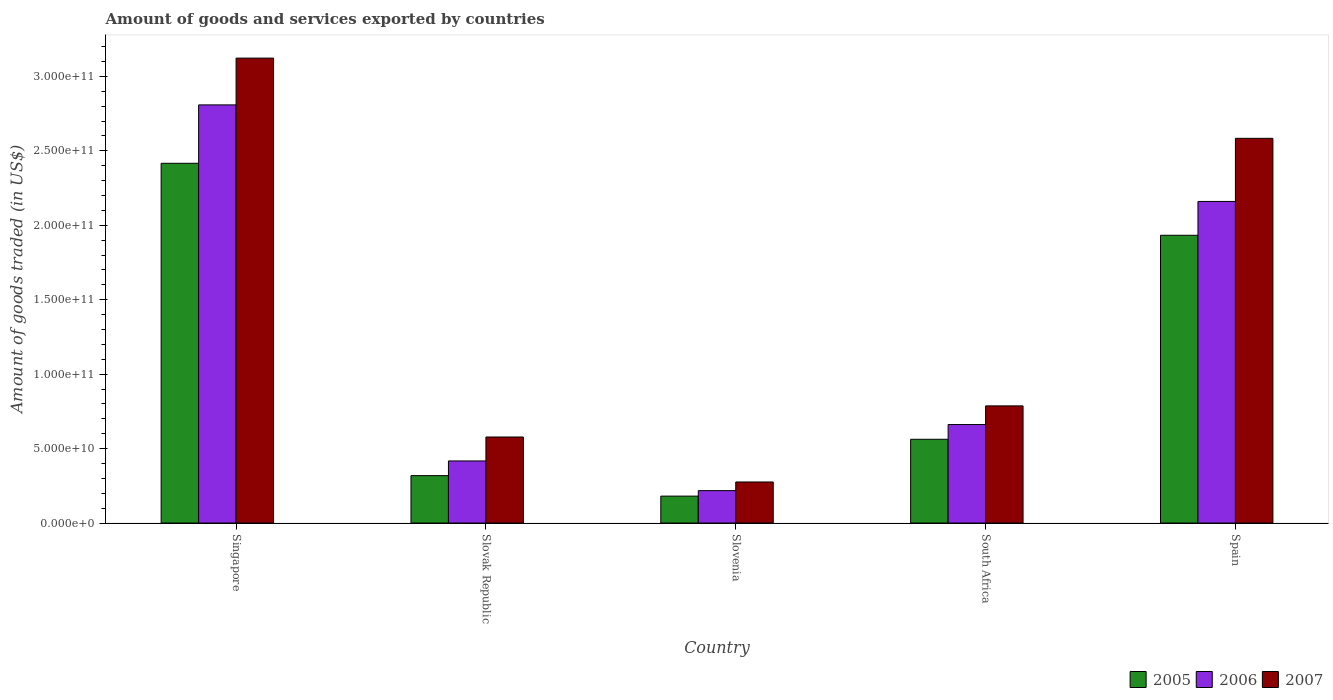How many different coloured bars are there?
Your response must be concise. 3. How many groups of bars are there?
Your response must be concise. 5. Are the number of bars on each tick of the X-axis equal?
Provide a short and direct response. Yes. What is the label of the 1st group of bars from the left?
Ensure brevity in your answer.  Singapore. In how many cases, is the number of bars for a given country not equal to the number of legend labels?
Give a very brief answer. 0. What is the total amount of goods and services exported in 2006 in Slovenia?
Provide a short and direct response. 2.18e+1. Across all countries, what is the maximum total amount of goods and services exported in 2007?
Make the answer very short. 3.12e+11. Across all countries, what is the minimum total amount of goods and services exported in 2005?
Your response must be concise. 1.81e+1. In which country was the total amount of goods and services exported in 2006 maximum?
Your answer should be very brief. Singapore. In which country was the total amount of goods and services exported in 2007 minimum?
Keep it short and to the point. Slovenia. What is the total total amount of goods and services exported in 2006 in the graph?
Your answer should be very brief. 6.27e+11. What is the difference between the total amount of goods and services exported in 2006 in Slovenia and that in Spain?
Provide a short and direct response. -1.94e+11. What is the difference between the total amount of goods and services exported in 2005 in South Africa and the total amount of goods and services exported in 2007 in Singapore?
Make the answer very short. -2.56e+11. What is the average total amount of goods and services exported in 2006 per country?
Ensure brevity in your answer.  1.25e+11. What is the difference between the total amount of goods and services exported of/in 2006 and total amount of goods and services exported of/in 2007 in South Africa?
Your answer should be very brief. -1.25e+1. What is the ratio of the total amount of goods and services exported in 2005 in South Africa to that in Spain?
Your answer should be compact. 0.29. Is the total amount of goods and services exported in 2006 in Slovak Republic less than that in Slovenia?
Your response must be concise. No. Is the difference between the total amount of goods and services exported in 2006 in Slovak Republic and Slovenia greater than the difference between the total amount of goods and services exported in 2007 in Slovak Republic and Slovenia?
Offer a terse response. No. What is the difference between the highest and the second highest total amount of goods and services exported in 2006?
Provide a succinct answer. 6.48e+1. What is the difference between the highest and the lowest total amount of goods and services exported in 2007?
Your answer should be compact. 2.85e+11. Is the sum of the total amount of goods and services exported in 2007 in South Africa and Spain greater than the maximum total amount of goods and services exported in 2006 across all countries?
Provide a succinct answer. Yes. Is it the case that in every country, the sum of the total amount of goods and services exported in 2005 and total amount of goods and services exported in 2007 is greater than the total amount of goods and services exported in 2006?
Your response must be concise. Yes. What is the difference between two consecutive major ticks on the Y-axis?
Your response must be concise. 5.00e+1. Does the graph contain grids?
Provide a short and direct response. No. How many legend labels are there?
Provide a succinct answer. 3. How are the legend labels stacked?
Make the answer very short. Horizontal. What is the title of the graph?
Provide a short and direct response. Amount of goods and services exported by countries. Does "2011" appear as one of the legend labels in the graph?
Provide a succinct answer. No. What is the label or title of the X-axis?
Offer a terse response. Country. What is the label or title of the Y-axis?
Offer a terse response. Amount of goods traded (in US$). What is the Amount of goods traded (in US$) in 2005 in Singapore?
Offer a very short reply. 2.42e+11. What is the Amount of goods traded (in US$) of 2006 in Singapore?
Offer a terse response. 2.81e+11. What is the Amount of goods traded (in US$) in 2007 in Singapore?
Provide a succinct answer. 3.12e+11. What is the Amount of goods traded (in US$) of 2005 in Slovak Republic?
Provide a short and direct response. 3.18e+1. What is the Amount of goods traded (in US$) of 2006 in Slovak Republic?
Your response must be concise. 4.17e+1. What is the Amount of goods traded (in US$) of 2007 in Slovak Republic?
Your response must be concise. 5.78e+1. What is the Amount of goods traded (in US$) of 2005 in Slovenia?
Your response must be concise. 1.81e+1. What is the Amount of goods traded (in US$) of 2006 in Slovenia?
Provide a succinct answer. 2.18e+1. What is the Amount of goods traded (in US$) in 2007 in Slovenia?
Make the answer very short. 2.76e+1. What is the Amount of goods traded (in US$) in 2005 in South Africa?
Ensure brevity in your answer.  5.63e+1. What is the Amount of goods traded (in US$) in 2006 in South Africa?
Ensure brevity in your answer.  6.62e+1. What is the Amount of goods traded (in US$) in 2007 in South Africa?
Give a very brief answer. 7.87e+1. What is the Amount of goods traded (in US$) of 2005 in Spain?
Your answer should be compact. 1.93e+11. What is the Amount of goods traded (in US$) of 2006 in Spain?
Your answer should be very brief. 2.16e+11. What is the Amount of goods traded (in US$) in 2007 in Spain?
Your answer should be very brief. 2.58e+11. Across all countries, what is the maximum Amount of goods traded (in US$) of 2005?
Offer a terse response. 2.42e+11. Across all countries, what is the maximum Amount of goods traded (in US$) in 2006?
Your answer should be very brief. 2.81e+11. Across all countries, what is the maximum Amount of goods traded (in US$) of 2007?
Provide a succinct answer. 3.12e+11. Across all countries, what is the minimum Amount of goods traded (in US$) in 2005?
Keep it short and to the point. 1.81e+1. Across all countries, what is the minimum Amount of goods traded (in US$) of 2006?
Make the answer very short. 2.18e+1. Across all countries, what is the minimum Amount of goods traded (in US$) in 2007?
Your answer should be very brief. 2.76e+1. What is the total Amount of goods traded (in US$) of 2005 in the graph?
Provide a short and direct response. 5.41e+11. What is the total Amount of goods traded (in US$) of 2006 in the graph?
Make the answer very short. 6.27e+11. What is the total Amount of goods traded (in US$) in 2007 in the graph?
Provide a succinct answer. 7.35e+11. What is the difference between the Amount of goods traded (in US$) of 2005 in Singapore and that in Slovak Republic?
Ensure brevity in your answer.  2.10e+11. What is the difference between the Amount of goods traded (in US$) of 2006 in Singapore and that in Slovak Republic?
Your response must be concise. 2.39e+11. What is the difference between the Amount of goods traded (in US$) in 2007 in Singapore and that in Slovak Republic?
Your response must be concise. 2.54e+11. What is the difference between the Amount of goods traded (in US$) in 2005 in Singapore and that in Slovenia?
Keep it short and to the point. 2.24e+11. What is the difference between the Amount of goods traded (in US$) in 2006 in Singapore and that in Slovenia?
Your response must be concise. 2.59e+11. What is the difference between the Amount of goods traded (in US$) in 2007 in Singapore and that in Slovenia?
Give a very brief answer. 2.85e+11. What is the difference between the Amount of goods traded (in US$) of 2005 in Singapore and that in South Africa?
Keep it short and to the point. 1.85e+11. What is the difference between the Amount of goods traded (in US$) of 2006 in Singapore and that in South Africa?
Give a very brief answer. 2.15e+11. What is the difference between the Amount of goods traded (in US$) of 2007 in Singapore and that in South Africa?
Offer a very short reply. 2.34e+11. What is the difference between the Amount of goods traded (in US$) in 2005 in Singapore and that in Spain?
Ensure brevity in your answer.  4.84e+1. What is the difference between the Amount of goods traded (in US$) in 2006 in Singapore and that in Spain?
Make the answer very short. 6.48e+1. What is the difference between the Amount of goods traded (in US$) in 2007 in Singapore and that in Spain?
Your answer should be compact. 5.39e+1. What is the difference between the Amount of goods traded (in US$) of 2005 in Slovak Republic and that in Slovenia?
Provide a succinct answer. 1.38e+1. What is the difference between the Amount of goods traded (in US$) in 2006 in Slovak Republic and that in Slovenia?
Offer a very short reply. 1.99e+1. What is the difference between the Amount of goods traded (in US$) in 2007 in Slovak Republic and that in Slovenia?
Your response must be concise. 3.02e+1. What is the difference between the Amount of goods traded (in US$) of 2005 in Slovak Republic and that in South Africa?
Your answer should be very brief. -2.44e+1. What is the difference between the Amount of goods traded (in US$) in 2006 in Slovak Republic and that in South Africa?
Your answer should be very brief. -2.45e+1. What is the difference between the Amount of goods traded (in US$) in 2007 in Slovak Republic and that in South Africa?
Ensure brevity in your answer.  -2.09e+1. What is the difference between the Amount of goods traded (in US$) of 2005 in Slovak Republic and that in Spain?
Your response must be concise. -1.61e+11. What is the difference between the Amount of goods traded (in US$) in 2006 in Slovak Republic and that in Spain?
Keep it short and to the point. -1.74e+11. What is the difference between the Amount of goods traded (in US$) of 2007 in Slovak Republic and that in Spain?
Your answer should be very brief. -2.01e+11. What is the difference between the Amount of goods traded (in US$) of 2005 in Slovenia and that in South Africa?
Offer a very short reply. -3.82e+1. What is the difference between the Amount of goods traded (in US$) of 2006 in Slovenia and that in South Africa?
Keep it short and to the point. -4.44e+1. What is the difference between the Amount of goods traded (in US$) of 2007 in Slovenia and that in South Africa?
Give a very brief answer. -5.11e+1. What is the difference between the Amount of goods traded (in US$) of 2005 in Slovenia and that in Spain?
Your answer should be very brief. -1.75e+11. What is the difference between the Amount of goods traded (in US$) in 2006 in Slovenia and that in Spain?
Make the answer very short. -1.94e+11. What is the difference between the Amount of goods traded (in US$) in 2007 in Slovenia and that in Spain?
Provide a short and direct response. -2.31e+11. What is the difference between the Amount of goods traded (in US$) of 2005 in South Africa and that in Spain?
Offer a very short reply. -1.37e+11. What is the difference between the Amount of goods traded (in US$) in 2006 in South Africa and that in Spain?
Keep it short and to the point. -1.50e+11. What is the difference between the Amount of goods traded (in US$) in 2007 in South Africa and that in Spain?
Keep it short and to the point. -1.80e+11. What is the difference between the Amount of goods traded (in US$) of 2005 in Singapore and the Amount of goods traded (in US$) of 2006 in Slovak Republic?
Offer a terse response. 2.00e+11. What is the difference between the Amount of goods traded (in US$) of 2005 in Singapore and the Amount of goods traded (in US$) of 2007 in Slovak Republic?
Your response must be concise. 1.84e+11. What is the difference between the Amount of goods traded (in US$) of 2006 in Singapore and the Amount of goods traded (in US$) of 2007 in Slovak Republic?
Your response must be concise. 2.23e+11. What is the difference between the Amount of goods traded (in US$) in 2005 in Singapore and the Amount of goods traded (in US$) in 2006 in Slovenia?
Provide a succinct answer. 2.20e+11. What is the difference between the Amount of goods traded (in US$) in 2005 in Singapore and the Amount of goods traded (in US$) in 2007 in Slovenia?
Provide a succinct answer. 2.14e+11. What is the difference between the Amount of goods traded (in US$) of 2006 in Singapore and the Amount of goods traded (in US$) of 2007 in Slovenia?
Your response must be concise. 2.53e+11. What is the difference between the Amount of goods traded (in US$) of 2005 in Singapore and the Amount of goods traded (in US$) of 2006 in South Africa?
Provide a short and direct response. 1.75e+11. What is the difference between the Amount of goods traded (in US$) in 2005 in Singapore and the Amount of goods traded (in US$) in 2007 in South Africa?
Provide a short and direct response. 1.63e+11. What is the difference between the Amount of goods traded (in US$) of 2006 in Singapore and the Amount of goods traded (in US$) of 2007 in South Africa?
Your response must be concise. 2.02e+11. What is the difference between the Amount of goods traded (in US$) in 2005 in Singapore and the Amount of goods traded (in US$) in 2006 in Spain?
Keep it short and to the point. 2.56e+1. What is the difference between the Amount of goods traded (in US$) in 2005 in Singapore and the Amount of goods traded (in US$) in 2007 in Spain?
Your response must be concise. -1.68e+1. What is the difference between the Amount of goods traded (in US$) in 2006 in Singapore and the Amount of goods traded (in US$) in 2007 in Spain?
Make the answer very short. 2.25e+1. What is the difference between the Amount of goods traded (in US$) in 2005 in Slovak Republic and the Amount of goods traded (in US$) in 2006 in Slovenia?
Offer a terse response. 1.01e+1. What is the difference between the Amount of goods traded (in US$) of 2005 in Slovak Republic and the Amount of goods traded (in US$) of 2007 in Slovenia?
Make the answer very short. 4.27e+09. What is the difference between the Amount of goods traded (in US$) in 2006 in Slovak Republic and the Amount of goods traded (in US$) in 2007 in Slovenia?
Your answer should be compact. 1.41e+1. What is the difference between the Amount of goods traded (in US$) in 2005 in Slovak Republic and the Amount of goods traded (in US$) in 2006 in South Africa?
Provide a succinct answer. -3.43e+1. What is the difference between the Amount of goods traded (in US$) in 2005 in Slovak Republic and the Amount of goods traded (in US$) in 2007 in South Africa?
Offer a terse response. -4.69e+1. What is the difference between the Amount of goods traded (in US$) of 2006 in Slovak Republic and the Amount of goods traded (in US$) of 2007 in South Africa?
Your answer should be very brief. -3.70e+1. What is the difference between the Amount of goods traded (in US$) in 2005 in Slovak Republic and the Amount of goods traded (in US$) in 2006 in Spain?
Ensure brevity in your answer.  -1.84e+11. What is the difference between the Amount of goods traded (in US$) of 2005 in Slovak Republic and the Amount of goods traded (in US$) of 2007 in Spain?
Give a very brief answer. -2.27e+11. What is the difference between the Amount of goods traded (in US$) of 2006 in Slovak Republic and the Amount of goods traded (in US$) of 2007 in Spain?
Provide a succinct answer. -2.17e+11. What is the difference between the Amount of goods traded (in US$) in 2005 in Slovenia and the Amount of goods traded (in US$) in 2006 in South Africa?
Your answer should be compact. -4.81e+1. What is the difference between the Amount of goods traded (in US$) of 2005 in Slovenia and the Amount of goods traded (in US$) of 2007 in South Africa?
Offer a terse response. -6.06e+1. What is the difference between the Amount of goods traded (in US$) in 2006 in Slovenia and the Amount of goods traded (in US$) in 2007 in South Africa?
Offer a very short reply. -5.69e+1. What is the difference between the Amount of goods traded (in US$) in 2005 in Slovenia and the Amount of goods traded (in US$) in 2006 in Spain?
Offer a very short reply. -1.98e+11. What is the difference between the Amount of goods traded (in US$) in 2005 in Slovenia and the Amount of goods traded (in US$) in 2007 in Spain?
Make the answer very short. -2.40e+11. What is the difference between the Amount of goods traded (in US$) in 2006 in Slovenia and the Amount of goods traded (in US$) in 2007 in Spain?
Your response must be concise. -2.37e+11. What is the difference between the Amount of goods traded (in US$) in 2005 in South Africa and the Amount of goods traded (in US$) in 2006 in Spain?
Your answer should be very brief. -1.60e+11. What is the difference between the Amount of goods traded (in US$) in 2005 in South Africa and the Amount of goods traded (in US$) in 2007 in Spain?
Offer a very short reply. -2.02e+11. What is the difference between the Amount of goods traded (in US$) of 2006 in South Africa and the Amount of goods traded (in US$) of 2007 in Spain?
Your answer should be very brief. -1.92e+11. What is the average Amount of goods traded (in US$) of 2005 per country?
Make the answer very short. 1.08e+11. What is the average Amount of goods traded (in US$) of 2006 per country?
Keep it short and to the point. 1.25e+11. What is the average Amount of goods traded (in US$) in 2007 per country?
Your answer should be very brief. 1.47e+11. What is the difference between the Amount of goods traded (in US$) of 2005 and Amount of goods traded (in US$) of 2006 in Singapore?
Offer a terse response. -3.92e+1. What is the difference between the Amount of goods traded (in US$) in 2005 and Amount of goods traded (in US$) in 2007 in Singapore?
Offer a terse response. -7.06e+1. What is the difference between the Amount of goods traded (in US$) in 2006 and Amount of goods traded (in US$) in 2007 in Singapore?
Your answer should be very brief. -3.14e+1. What is the difference between the Amount of goods traded (in US$) of 2005 and Amount of goods traded (in US$) of 2006 in Slovak Republic?
Offer a very short reply. -9.86e+09. What is the difference between the Amount of goods traded (in US$) of 2005 and Amount of goods traded (in US$) of 2007 in Slovak Republic?
Keep it short and to the point. -2.59e+1. What is the difference between the Amount of goods traded (in US$) of 2006 and Amount of goods traded (in US$) of 2007 in Slovak Republic?
Provide a short and direct response. -1.61e+1. What is the difference between the Amount of goods traded (in US$) in 2005 and Amount of goods traded (in US$) in 2006 in Slovenia?
Offer a terse response. -3.69e+09. What is the difference between the Amount of goods traded (in US$) in 2005 and Amount of goods traded (in US$) in 2007 in Slovenia?
Keep it short and to the point. -9.50e+09. What is the difference between the Amount of goods traded (in US$) in 2006 and Amount of goods traded (in US$) in 2007 in Slovenia?
Your answer should be very brief. -5.81e+09. What is the difference between the Amount of goods traded (in US$) of 2005 and Amount of goods traded (in US$) of 2006 in South Africa?
Offer a very short reply. -9.90e+09. What is the difference between the Amount of goods traded (in US$) of 2005 and Amount of goods traded (in US$) of 2007 in South Africa?
Offer a very short reply. -2.24e+1. What is the difference between the Amount of goods traded (in US$) of 2006 and Amount of goods traded (in US$) of 2007 in South Africa?
Your response must be concise. -1.25e+1. What is the difference between the Amount of goods traded (in US$) in 2005 and Amount of goods traded (in US$) in 2006 in Spain?
Give a very brief answer. -2.27e+1. What is the difference between the Amount of goods traded (in US$) in 2005 and Amount of goods traded (in US$) in 2007 in Spain?
Keep it short and to the point. -6.51e+1. What is the difference between the Amount of goods traded (in US$) in 2006 and Amount of goods traded (in US$) in 2007 in Spain?
Provide a short and direct response. -4.24e+1. What is the ratio of the Amount of goods traded (in US$) of 2005 in Singapore to that in Slovak Republic?
Offer a terse response. 7.59. What is the ratio of the Amount of goods traded (in US$) in 2006 in Singapore to that in Slovak Republic?
Offer a very short reply. 6.73. What is the ratio of the Amount of goods traded (in US$) of 2007 in Singapore to that in Slovak Republic?
Your answer should be compact. 5.4. What is the ratio of the Amount of goods traded (in US$) of 2005 in Singapore to that in Slovenia?
Your answer should be very brief. 13.37. What is the ratio of the Amount of goods traded (in US$) in 2006 in Singapore to that in Slovenia?
Your answer should be compact. 12.9. What is the ratio of the Amount of goods traded (in US$) in 2007 in Singapore to that in Slovenia?
Offer a terse response. 11.33. What is the ratio of the Amount of goods traded (in US$) of 2005 in Singapore to that in South Africa?
Offer a terse response. 4.29. What is the ratio of the Amount of goods traded (in US$) of 2006 in Singapore to that in South Africa?
Give a very brief answer. 4.25. What is the ratio of the Amount of goods traded (in US$) of 2007 in Singapore to that in South Africa?
Your answer should be very brief. 3.97. What is the ratio of the Amount of goods traded (in US$) of 2005 in Singapore to that in Spain?
Provide a short and direct response. 1.25. What is the ratio of the Amount of goods traded (in US$) of 2006 in Singapore to that in Spain?
Offer a very short reply. 1.3. What is the ratio of the Amount of goods traded (in US$) of 2007 in Singapore to that in Spain?
Give a very brief answer. 1.21. What is the ratio of the Amount of goods traded (in US$) of 2005 in Slovak Republic to that in Slovenia?
Offer a terse response. 1.76. What is the ratio of the Amount of goods traded (in US$) of 2006 in Slovak Republic to that in Slovenia?
Your response must be concise. 1.92. What is the ratio of the Amount of goods traded (in US$) of 2007 in Slovak Republic to that in Slovenia?
Give a very brief answer. 2.1. What is the ratio of the Amount of goods traded (in US$) in 2005 in Slovak Republic to that in South Africa?
Offer a very short reply. 0.57. What is the ratio of the Amount of goods traded (in US$) in 2006 in Slovak Republic to that in South Africa?
Give a very brief answer. 0.63. What is the ratio of the Amount of goods traded (in US$) of 2007 in Slovak Republic to that in South Africa?
Keep it short and to the point. 0.73. What is the ratio of the Amount of goods traded (in US$) in 2005 in Slovak Republic to that in Spain?
Make the answer very short. 0.16. What is the ratio of the Amount of goods traded (in US$) of 2006 in Slovak Republic to that in Spain?
Provide a succinct answer. 0.19. What is the ratio of the Amount of goods traded (in US$) of 2007 in Slovak Republic to that in Spain?
Provide a short and direct response. 0.22. What is the ratio of the Amount of goods traded (in US$) in 2005 in Slovenia to that in South Africa?
Give a very brief answer. 0.32. What is the ratio of the Amount of goods traded (in US$) of 2006 in Slovenia to that in South Africa?
Your answer should be very brief. 0.33. What is the ratio of the Amount of goods traded (in US$) in 2007 in Slovenia to that in South Africa?
Provide a short and direct response. 0.35. What is the ratio of the Amount of goods traded (in US$) of 2005 in Slovenia to that in Spain?
Keep it short and to the point. 0.09. What is the ratio of the Amount of goods traded (in US$) of 2006 in Slovenia to that in Spain?
Make the answer very short. 0.1. What is the ratio of the Amount of goods traded (in US$) of 2007 in Slovenia to that in Spain?
Offer a very short reply. 0.11. What is the ratio of the Amount of goods traded (in US$) of 2005 in South Africa to that in Spain?
Your answer should be very brief. 0.29. What is the ratio of the Amount of goods traded (in US$) of 2006 in South Africa to that in Spain?
Keep it short and to the point. 0.31. What is the ratio of the Amount of goods traded (in US$) in 2007 in South Africa to that in Spain?
Make the answer very short. 0.3. What is the difference between the highest and the second highest Amount of goods traded (in US$) of 2005?
Your answer should be very brief. 4.84e+1. What is the difference between the highest and the second highest Amount of goods traded (in US$) of 2006?
Offer a terse response. 6.48e+1. What is the difference between the highest and the second highest Amount of goods traded (in US$) in 2007?
Your answer should be very brief. 5.39e+1. What is the difference between the highest and the lowest Amount of goods traded (in US$) in 2005?
Provide a short and direct response. 2.24e+11. What is the difference between the highest and the lowest Amount of goods traded (in US$) of 2006?
Make the answer very short. 2.59e+11. What is the difference between the highest and the lowest Amount of goods traded (in US$) in 2007?
Provide a short and direct response. 2.85e+11. 